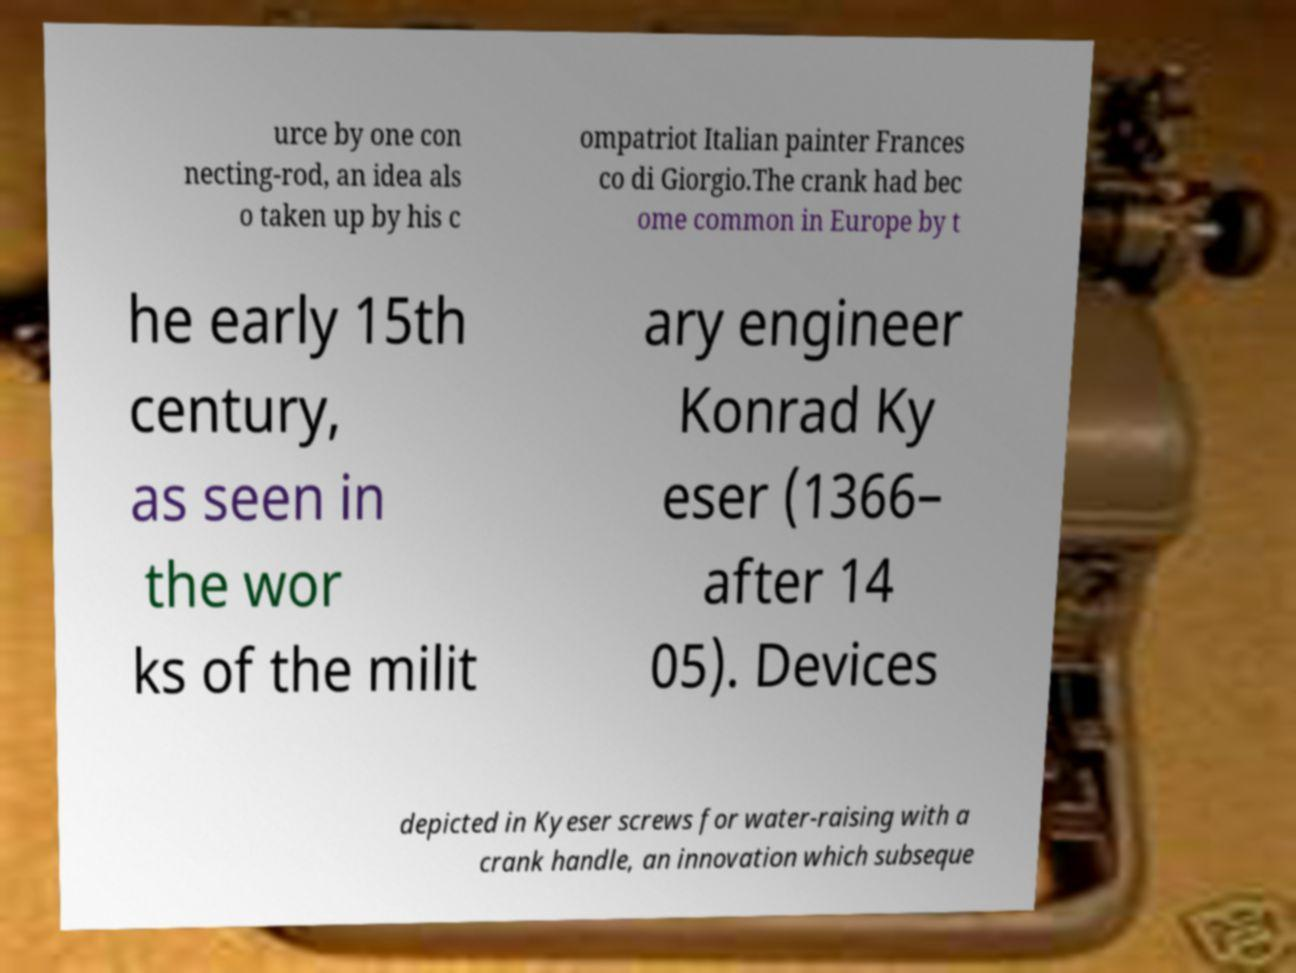I need the written content from this picture converted into text. Can you do that? urce by one con necting-rod, an idea als o taken up by his c ompatriot Italian painter Frances co di Giorgio.The crank had bec ome common in Europe by t he early 15th century, as seen in the wor ks of the milit ary engineer Konrad Ky eser (1366– after 14 05). Devices depicted in Kyeser screws for water-raising with a crank handle, an innovation which subseque 